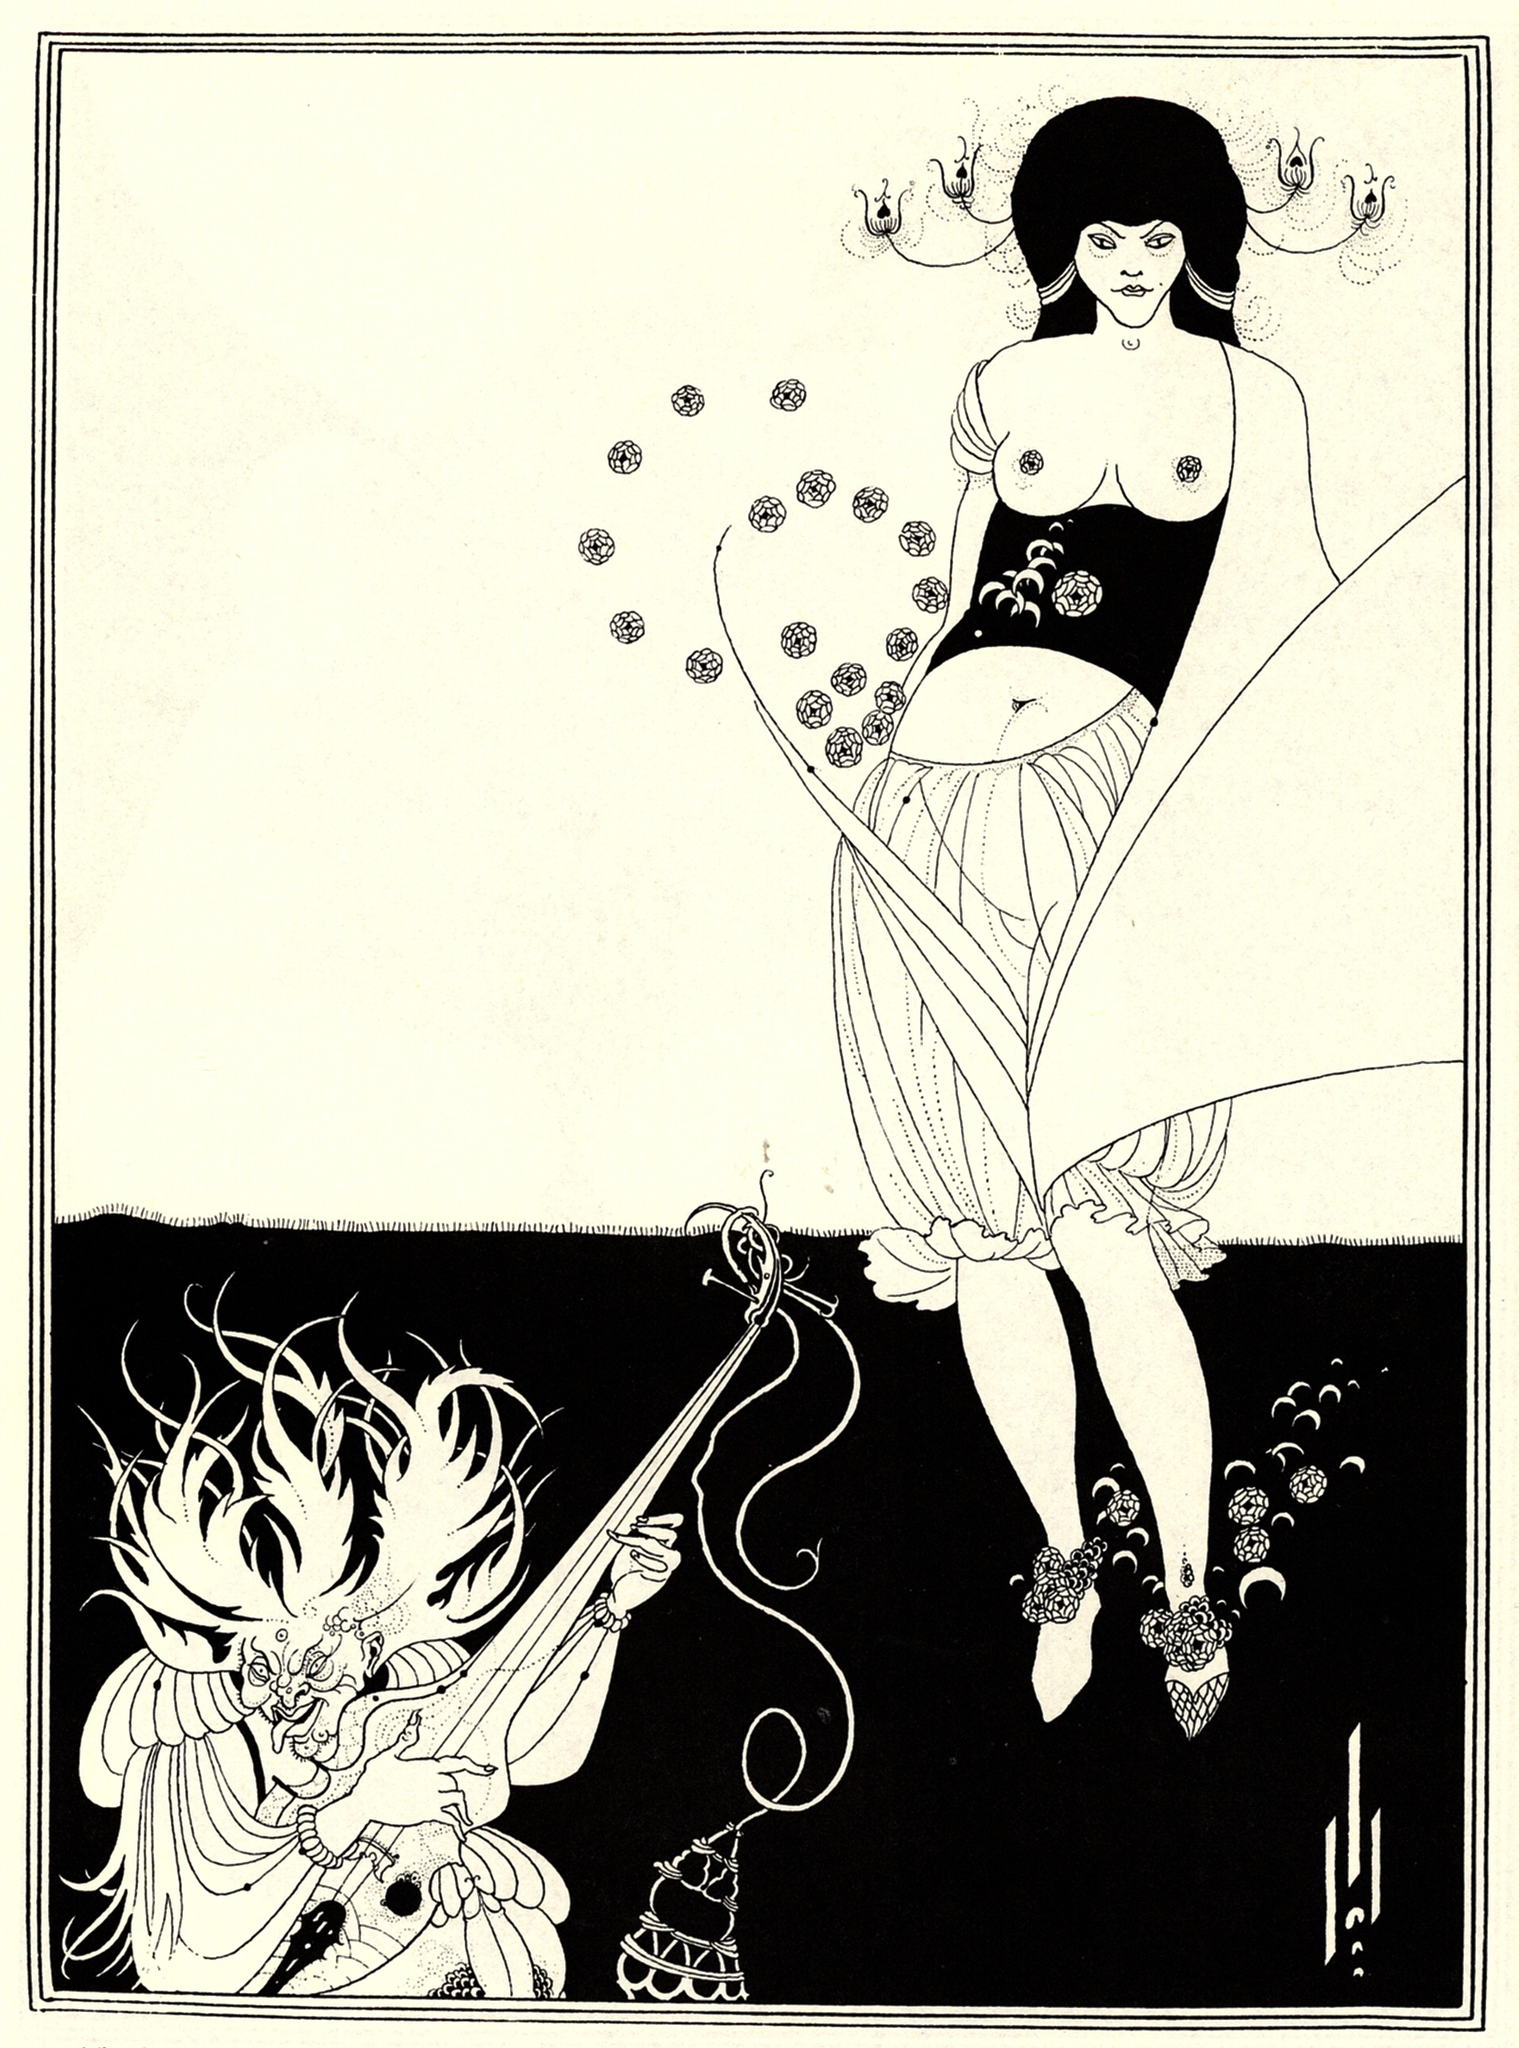What stands out about the stylistic choices in this artwork? The artist employs a striking contrast between black and white to emphasize the intricate details of both the woman and the dragon. This use of high contrast, combined with flowing lines and detailed floral patterns, is characteristic of the Art Nouveau style. The interplay of natural forms and fantastical elements creates a dynamic and captivating composition. Could you tell me more about the symbolism of the flowers in the artwork? Certainly! The flowers in this artwork symbolize a connection to nature, which is a common theme in Art Nouveau. The floral patterns on the woman's dress and the dragon's adornments may represent beauty, growth, and harmony with the natural world. These symbols unify the two figures, despite their stark differences, suggesting a balance between human and fantastical elements. 